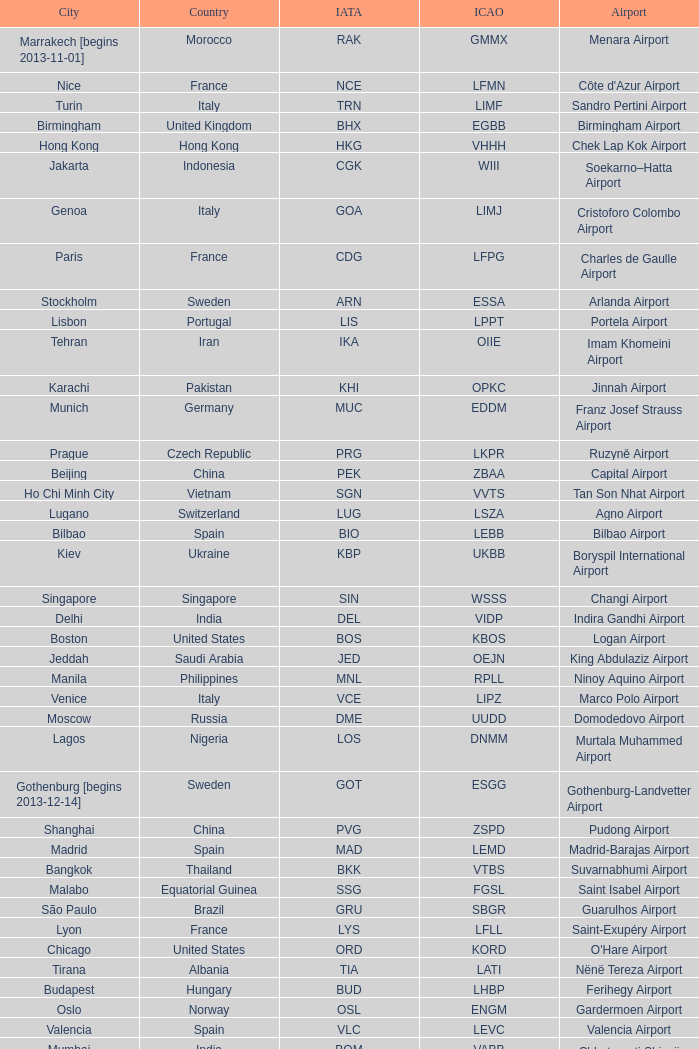Which city has the IATA SSG? Malabo. Could you parse the entire table? {'header': ['City', 'Country', 'IATA', 'ICAO', 'Airport'], 'rows': [['Marrakech [begins 2013-11-01]', 'Morocco', 'RAK', 'GMMX', 'Menara Airport'], ['Nice', 'France', 'NCE', 'LFMN', "Côte d'Azur Airport"], ['Turin', 'Italy', 'TRN', 'LIMF', 'Sandro Pertini Airport'], ['Birmingham', 'United Kingdom', 'BHX', 'EGBB', 'Birmingham Airport'], ['Hong Kong', 'Hong Kong', 'HKG', 'VHHH', 'Chek Lap Kok Airport'], ['Jakarta', 'Indonesia', 'CGK', 'WIII', 'Soekarno–Hatta Airport'], ['Genoa', 'Italy', 'GOA', 'LIMJ', 'Cristoforo Colombo Airport'], ['Paris', 'France', 'CDG', 'LFPG', 'Charles de Gaulle Airport'], ['Stockholm', 'Sweden', 'ARN', 'ESSA', 'Arlanda Airport'], ['Lisbon', 'Portugal', 'LIS', 'LPPT', 'Portela Airport'], ['Tehran', 'Iran', 'IKA', 'OIIE', 'Imam Khomeini Airport'], ['Karachi', 'Pakistan', 'KHI', 'OPKC', 'Jinnah Airport'], ['Munich', 'Germany', 'MUC', 'EDDM', 'Franz Josef Strauss Airport'], ['Prague', 'Czech Republic', 'PRG', 'LKPR', 'Ruzyně Airport'], ['Beijing', 'China', 'PEK', 'ZBAA', 'Capital Airport'], ['Ho Chi Minh City', 'Vietnam', 'SGN', 'VVTS', 'Tan Son Nhat Airport'], ['Lugano', 'Switzerland', 'LUG', 'LSZA', 'Agno Airport'], ['Bilbao', 'Spain', 'BIO', 'LEBB', 'Bilbao Airport'], ['Kiev', 'Ukraine', 'KBP', 'UKBB', 'Boryspil International Airport'], ['Singapore', 'Singapore', 'SIN', 'WSSS', 'Changi Airport'], ['Delhi', 'India', 'DEL', 'VIDP', 'Indira Gandhi Airport'], ['Boston', 'United States', 'BOS', 'KBOS', 'Logan Airport'], ['Jeddah', 'Saudi Arabia', 'JED', 'OEJN', 'King Abdulaziz Airport'], ['Manila', 'Philippines', 'MNL', 'RPLL', 'Ninoy Aquino Airport'], ['Venice', 'Italy', 'VCE', 'LIPZ', 'Marco Polo Airport'], ['Moscow', 'Russia', 'DME', 'UUDD', 'Domodedovo Airport'], ['Lagos', 'Nigeria', 'LOS', 'DNMM', 'Murtala Muhammed Airport'], ['Gothenburg [begins 2013-12-14]', 'Sweden', 'GOT', 'ESGG', 'Gothenburg-Landvetter Airport'], ['Shanghai', 'China', 'PVG', 'ZSPD', 'Pudong Airport'], ['Madrid', 'Spain', 'MAD', 'LEMD', 'Madrid-Barajas Airport'], ['Bangkok', 'Thailand', 'BKK', 'VTBS', 'Suvarnabhumi Airport'], ['Malabo', 'Equatorial Guinea', 'SSG', 'FGSL', 'Saint Isabel Airport'], ['São Paulo', 'Brazil', 'GRU', 'SBGR', 'Guarulhos Airport'], ['Lyon', 'France', 'LYS', 'LFLL', 'Saint-Exupéry Airport'], ['Chicago', 'United States', 'ORD', 'KORD', "O'Hare Airport"], ['Tirana', 'Albania', 'TIA', 'LATI', 'Nënë Tereza Airport'], ['Budapest', 'Hungary', 'BUD', 'LHBP', 'Ferihegy Airport'], ['Oslo', 'Norway', 'OSL', 'ENGM', 'Gardermoen Airport'], ['Valencia', 'Spain', 'VLC', 'LEVC', 'Valencia Airport'], ['Mumbai', 'India', 'BOM', 'VABB', 'Chhatrapati Shivaji Airport'], ['Vienna', 'Austria', 'VIE', 'LOWW', 'Schwechat Airport'], ['Warsaw', 'Poland', 'WAW', 'EPWA', 'Frederic Chopin Airport'], ['Stuttgart', 'Germany', 'STR', 'EDDS', 'Echterdingen Airport'], ['London', 'United Kingdom', 'LHR', 'EGLL', 'Heathrow Airport'], ['Milan', 'Italy', 'MXP', 'LIMC', 'Malpensa Airport'], ['Tokyo', 'Japan', 'NRT', 'RJAA', 'Narita Airport'], ['Bucharest', 'Romania', 'OTP', 'LROP', 'Otopeni Airport'], ['Helsinki', 'Finland', 'HEL', 'EFHK', 'Vantaa Airport'], ['Zurich', 'Switzerland', 'ZRH', 'LSZH', 'Zurich Airport'], ['Tunis', 'Tunisia', 'TUN', 'DTTA', 'Carthage Airport'], ['Newark', 'United States', 'EWR', 'KEWR', 'Liberty Airport'], ['Malaga', 'Spain', 'AGP', 'LEMG', 'Málaga-Costa del Sol Airport'], ['Washington DC', 'United States', 'IAD', 'KIAD', 'Dulles Airport'], ['Florence', 'Italy', 'FLR', 'LIRQ', 'Peretola Airport'], ['Miami', 'United States', 'MIA', 'KMIA', 'Miami Airport'], ['Dar es Salaam', 'Tanzania', 'DAR', 'HTDA', 'Julius Nyerere Airport'], ['Manchester', 'United Kingdom', 'MAN', 'EGCC', 'Ringway Airport'], ['Barcelona', 'Spain', 'BCN', 'LEBL', 'Barcelona-El Prat Airport'], ['Beirut', 'Lebanon', 'BEY', 'OLBA', 'Rafic Hariri Airport'], ['Luxembourg City', 'Luxembourg', 'LUX', 'ELLX', 'Findel Airport'], ['Caracas', 'Venezuela', 'CCS', 'SVMI', 'Simón Bolívar Airport'], ['Palma de Mallorca', 'Spain', 'PMI', 'LFPA', 'Palma de Mallorca Airport'], ['Seattle', 'United States', 'SEA', 'KSEA', 'Sea-Tac Airport'], ['Riga', 'Latvia', 'RIX', 'EVRA', 'Riga Airport'], ['Montreal', 'Canada', 'YUL', 'CYUL', 'Pierre Elliott Trudeau Airport'], ['Geneva', 'Switzerland', 'GVA', 'LSGG', 'Cointrin Airport'], ['Saint Petersburg', 'Russia', 'LED', 'ULLI', 'Pulkovo Airport'], ['Rio de Janeiro [resumes 2014-7-14]', 'Brazil', 'GIG', 'SBGL', 'Galeão Airport'], ['Rome', 'Italy', 'FCO', 'LIRF', 'Leonardo da Vinci Airport'], ['Skopje', 'Republic of Macedonia', 'SKP', 'LWSK', 'Alexander the Great Airport'], ['Muscat', 'Oman', 'MCT', 'OOMS', 'Seeb Airport'], ['Toronto', 'Canada', 'YYZ', 'CYYZ', 'Pearson Airport'], ['Riyadh', 'Saudi Arabia', 'RUH', 'OERK', 'King Khalid Airport'], ['Tripoli', 'Libya', 'TIP', 'HLLT', 'Tripoli Airport'], ['Dubai', 'United Arab Emirates', 'DXB', 'OMDB', 'Dubai Airport'], ['Atlanta', 'United States', 'ATL', 'KATL', 'Hartsfield–Jackson Airport'], ['Buenos Aires', 'Argentina', 'EZE', 'SAEZ', 'Ministro Pistarini Airport (Ezeiza)'], ['Cairo', 'Egypt', 'CAI', 'HECA', 'Cairo Airport'], ['New York City', 'United States', 'JFK', 'KJFK', 'John F Kennedy Airport'], ['Abu Dhabi', 'United Arab Emirates', 'AUH', 'OMAA', 'Abu Dhabi Airport'], ['Yaounde', 'Cameroon', 'NSI', 'FKYS', 'Yaounde Nsimalen Airport'], ['Accra', 'Ghana', 'ACC', 'DGAA', 'Kotoka Airport'], ['Istanbul', 'Turkey', 'IST', 'LTBA', 'Atatürk Airport'], ['Yerevan', 'Armenia', 'EVN', 'UDYZ', 'Zvartnots Airport'], ['Taipei', 'Taiwan', 'TPE', 'RCTP', 'Taoyuan Airport'], ['Düsseldorf', 'Germany', 'DUS', 'EDDL', 'Lohausen Airport'], ['Minneapolis', 'United States', 'MSP', 'KMSP', 'Minneapolis Airport'], ['Berlin', 'Germany', 'TXL', 'EDDT', 'Tegel Airport'], ['Hamburg', 'Germany', 'HAM', 'EDDH', 'Fuhlsbüttel Airport'], ['Sofia', 'Bulgaria', 'SOF', 'LBSF', 'Vrazhdebna Airport'], ['Santiago', 'Chile', 'SCL', 'SCEL', 'Comodoro Arturo Benitez Airport'], ['Frankfurt', 'Germany', 'FRA', 'EDDF', 'Frankfurt am Main Airport'], ['Brussels', 'Belgium', 'BRU', 'EBBR', 'Brussels Airport'], ['Benghazi', 'Libya', 'BEN', 'HLLB', 'Benina Airport'], ['Los Angeles', 'United States', 'LAX', 'KLAX', 'Los Angeles International Airport'], ['Hannover', 'Germany', 'HAJ', 'EDDV', 'Langenhagen Airport'], ['Nuremberg', 'Germany', 'NUE', 'EDDN', 'Nuremberg Airport'], ['Casablanca', 'Morocco', 'CMN', 'GMMN', 'Mohammed V Airport'], ['Basel Mulhouse Freiburg', 'Switzerland France Germany', 'BSL MLH EAP', 'LFSB', 'Euro Airport'], ['Dublin', 'Ireland', 'DUB', 'EIDW', 'Dublin Airport'], ['Thessaloniki', 'Greece', 'SKG', 'LGTS', 'Macedonia Airport'], ['Sarajevo', 'Bosnia and Herzegovina', 'SJJ', 'LQSA', 'Butmir Airport'], ['London', 'United Kingdom', 'LCY', 'EGLC', 'City Airport'], ['Porto', 'Portugal', 'OPO', 'LPPR', 'Francisco de Sa Carneiro Airport'], ['Belgrade', 'Serbia', 'BEG', 'LYBE', 'Nikola Tesla Airport'], ['Amsterdam', 'Netherlands', 'AMS', 'EHAM', 'Amsterdam Airport Schiphol'], ['Tel Aviv', 'Israel', 'TLV', 'LLBG', 'Ben Gurion Airport'], ['Copenhagen', 'Denmark', 'CPH', 'EKCH', 'Kastrup Airport'], ['Nairobi', 'Kenya', 'NBO', 'HKJK', 'Jomo Kenyatta Airport'], ['Douala', 'Cameroon', 'DLA', 'FKKD', 'Douala Airport'], ['Johannesburg', 'South Africa', 'JNB', 'FAJS', 'OR Tambo Airport'], ['Libreville', 'Gabon', 'LBV', 'FOOL', "Leon M'ba Airport"], ['Athens', 'Greece', 'ATH', 'LGAV', 'Eleftherios Venizelos Airport'], ['London [begins 2013-12-14]', 'United Kingdom', 'LGW', 'EGKK', 'Gatwick Airport'], ['San Francisco', 'United States', 'SFO', 'KSFO', 'San Francisco Airport']]} 